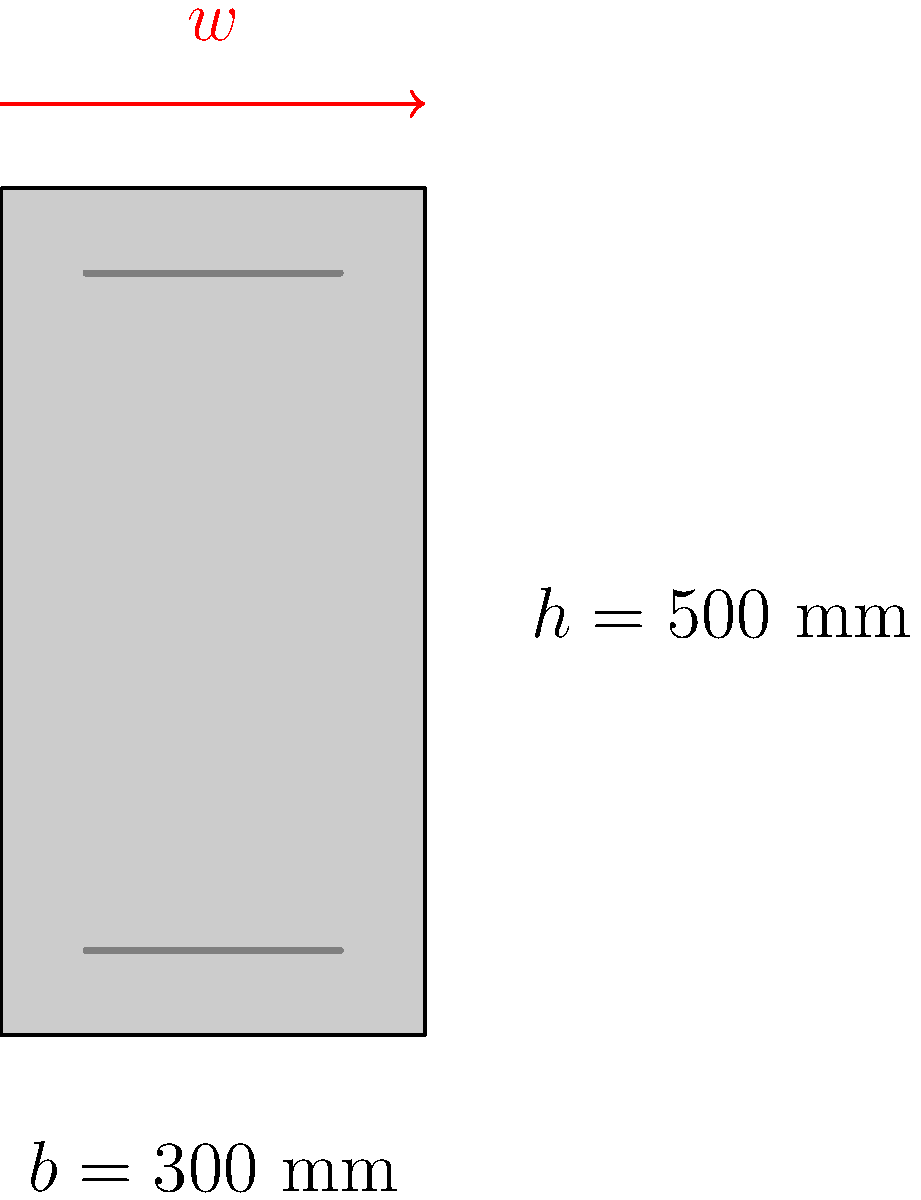A reinforced concrete beam with a rectangular cross-section of width $b = 300$ mm and height $h = 500$ mm is subjected to a uniformly distributed load $w$. The beam is simply supported with a span of 6 meters. Given that the concrete strength $f'_c = 30$ MPa and the yield strength of steel $f_y = 420$ MPa, determine the maximum bending moment capacity $M_n$ of the beam cross-section. Assume the effective depth $d = 450$ mm and the area of tension reinforcement $A_s = 1200$ mm². To solve this problem, we'll follow these steps:

1) First, calculate the depth of the compression block:
   $$a = \frac{A_s f_y}{0.85 f'_c b}$$
   $$a = \frac{1200 \times 420}{0.85 \times 30 \times 300} = 98.04 \text{ mm}$$

2) Check if the section is tension-controlled:
   $$c = \frac{a}{0.85} = \frac{98.04}{0.85} = 115.34 \text{ mm}$$
   $$\frac{c}{d} = \frac{115.34}{450} = 0.256 < 0.375$$
   The section is tension-controlled, so $\phi = 0.9$

3) Calculate the nominal moment capacity:
   $$M_n = A_s f_y (d - \frac{a}{2})$$
   $$M_n = 1200 \times 420 \times (450 - \frac{98.04}{2})$$
   $$M_n = 201.98 \times 10^6 \text{ N-mm} = 201.98 \text{ kN-m}$$

4) The design moment capacity is:
   $$\phi M_n = 0.9 \times 201.98 = 181.78 \text{ kN-m}$$

Therefore, the maximum bending moment capacity of the beam cross-section is 201.98 kN-m.
Answer: 201.98 kN-m 